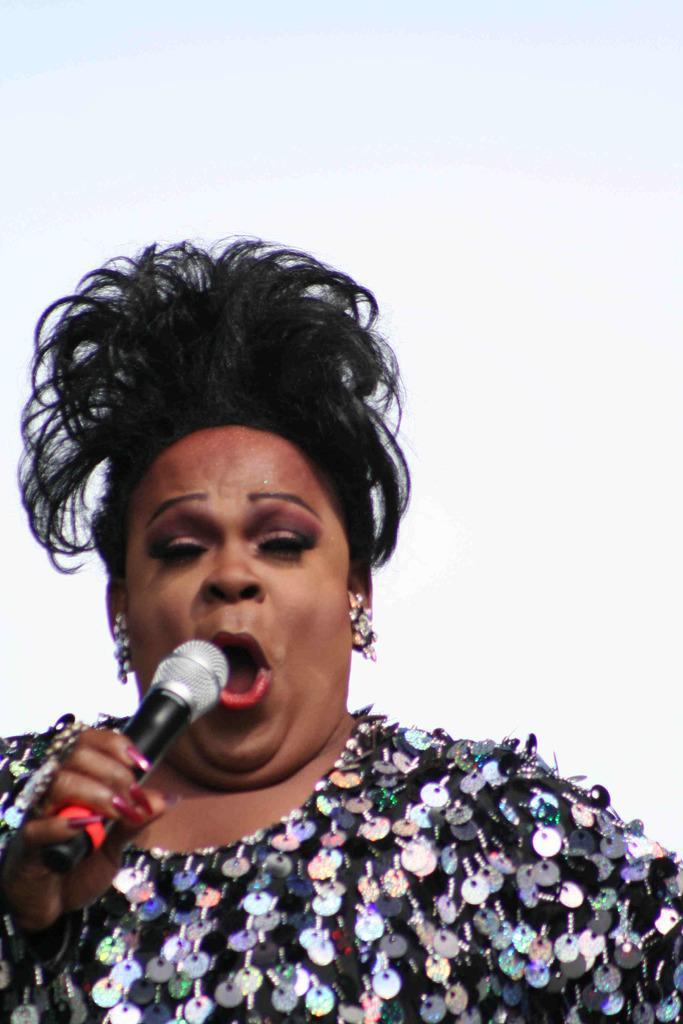In one or two sentences, can you explain what this image depicts? In this image i can see a woman singing holding a microphone. 